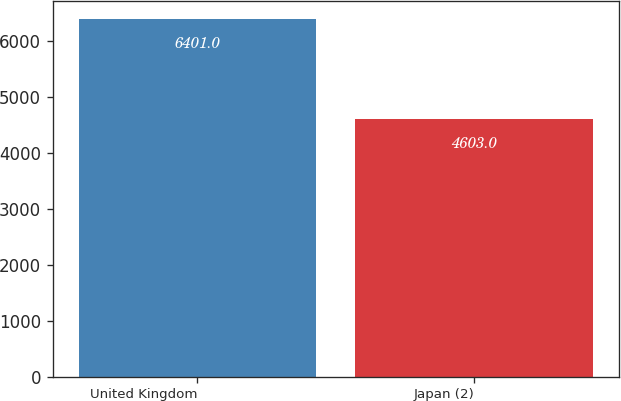<chart> <loc_0><loc_0><loc_500><loc_500><bar_chart><fcel>United Kingdom<fcel>Japan (2)<nl><fcel>6401<fcel>4603<nl></chart> 